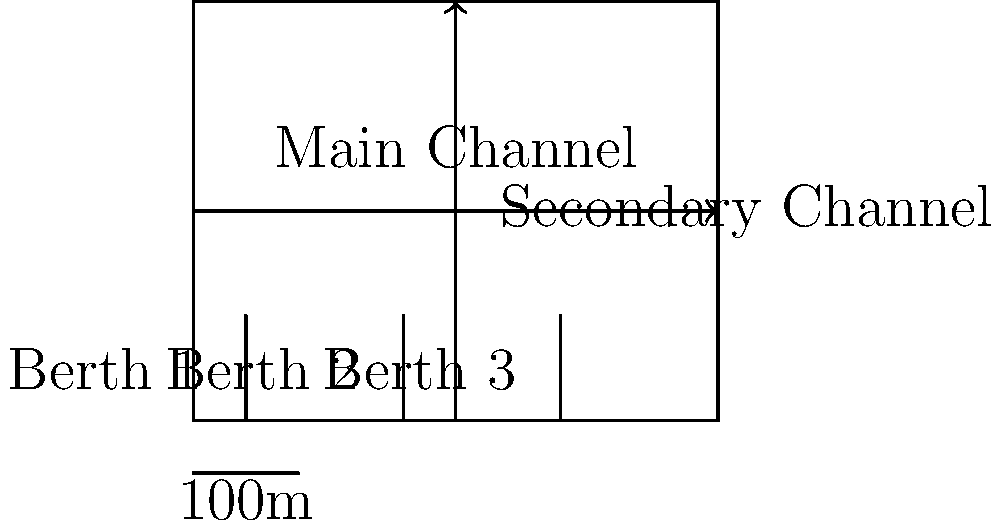As a naval officer, you are tasked with evaluating a proposed harbor layout. The design features three berths and two perpendicular navigation channels. Given that the main channel width is 60 meters and the secondary channel width is 40 meters, what is the minimum safe distance between Berth 2 and Berth 3 to allow for the safe passage of vessels in both channels simultaneously? To determine the minimum safe distance between Berth 2 and Berth 3, we need to consider the following steps:

1. Identify the critical area: The intersection of the main and secondary channels.

2. Consider channel widths:
   - Main channel width = 60 meters
   - Secondary channel width = 40 meters

3. Calculate the diagonal distance across the intersection:
   Using the Pythagorean theorem: $\sqrt{60^2 + 40^2} = \sqrt{3600 + 1600} = \sqrt{5200} \approx 72.11$ meters

4. Add safety margins:
   - Typically, a safety margin of 10% of the channel width is added on each side.
   - For the main channel: $60 * 0.1 * 2 = 12$ meters
   - For the secondary channel: $40 * 0.1 * 2 = 8$ meters

5. Calculate the total safe distance:
   $72.11 + 12 + 8 = 92.11$ meters

6. Round up for additional safety:
   Minimum safe distance ≈ 95 meters

Therefore, to ensure safe passage of vessels in both channels simultaneously, the minimum distance between Berth 2 and Berth 3 should be at least 95 meters.
Answer: 95 meters 